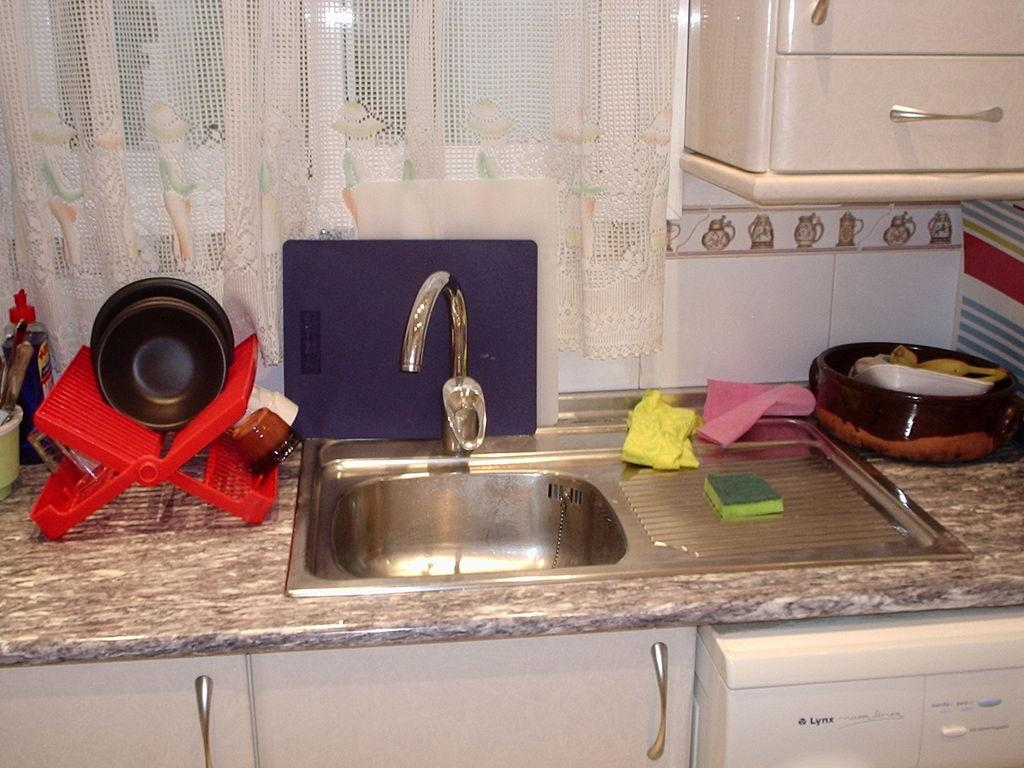Provide a one-sentence caption for the provided image. The white dishwasher is manufactured by the Lynx company. 